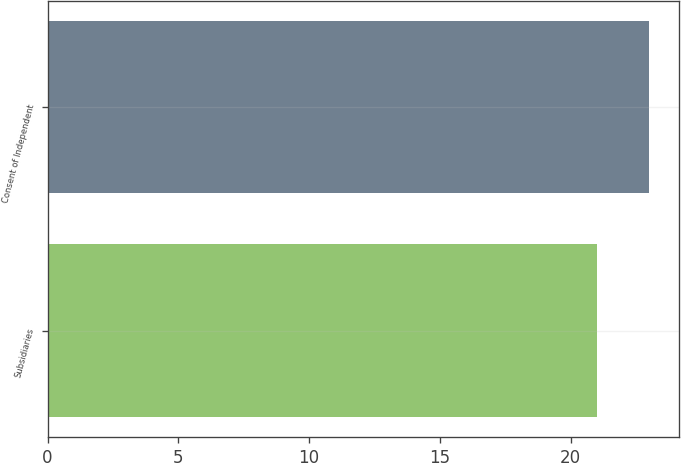<chart> <loc_0><loc_0><loc_500><loc_500><bar_chart><fcel>Subsidiaries<fcel>Consent of Independent<nl><fcel>21<fcel>23<nl></chart> 